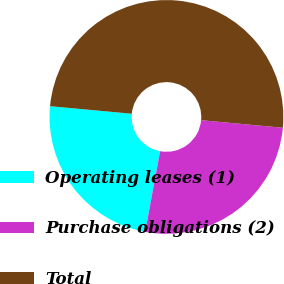<chart> <loc_0><loc_0><loc_500><loc_500><pie_chart><fcel>Operating leases (1)<fcel>Purchase obligations (2)<fcel>Total<nl><fcel>23.56%<fcel>26.44%<fcel>50.0%<nl></chart> 